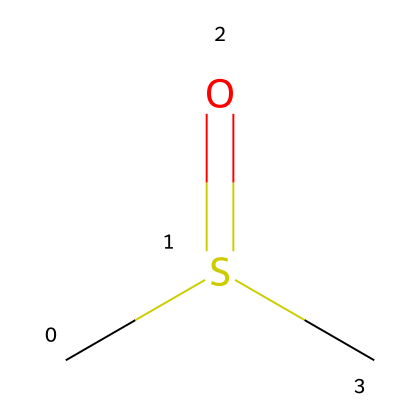What is the molecular formula of this compound? The SMILES representation indicates two carbon (C) atoms, one sulfur (S) atom, and one oxygen (O) atom. Thus, the molecular formula can be derived directly: C2H6OS.
Answer: C2H6OS How many atoms are in this molecule? From the molecular formula C2H6OS, we see there are two carbon atoms, six hydrogen atoms, one sulfur atom, and one oxygen atom, which sums up to 10 atoms in total (2 + 6 + 1 + 1 = 10).
Answer: 10 What is the functional group present in this compound? The presence of the sulfoxide (indicated by the S(=O) structure) shows that the functional group is a sulfoxide.
Answer: sulfoxide What is the hybridization of the carbon atoms in this compound? Each carbon is bonded to three atoms (two hydrogens and the sulfur atom), indicating they are sp3 hybridized, as each has four orbitals involved in bonding.
Answer: sp3 What type of compound is dimethyl sulfoxide classified as? Dimethyl sulfoxide has a sulfur atom bonded to oxygen and is classified as an organosulfur compound due to the presence of sulfur in its structure.
Answer: organosulfur What is the characteristic property of dimethyl sulfoxide in terms of solubility? Dimethyl sulfoxide is known to be a polar aprotic solvent, which means it can dissolve both polar and nonpolar substances due to its ability to mix well with a wide variety of chemicals.
Answer: polar aprotic solvent How does the sulfur atom in this compound influence its reactivity? The sulfur atom is capable of forming a variety of bonds and understands oxidation states, making the compound reactive with nucleophiles and electrophiles alike, influencing its overall behavior in reactions.
Answer: reactive with nucleophiles and electrophiles 